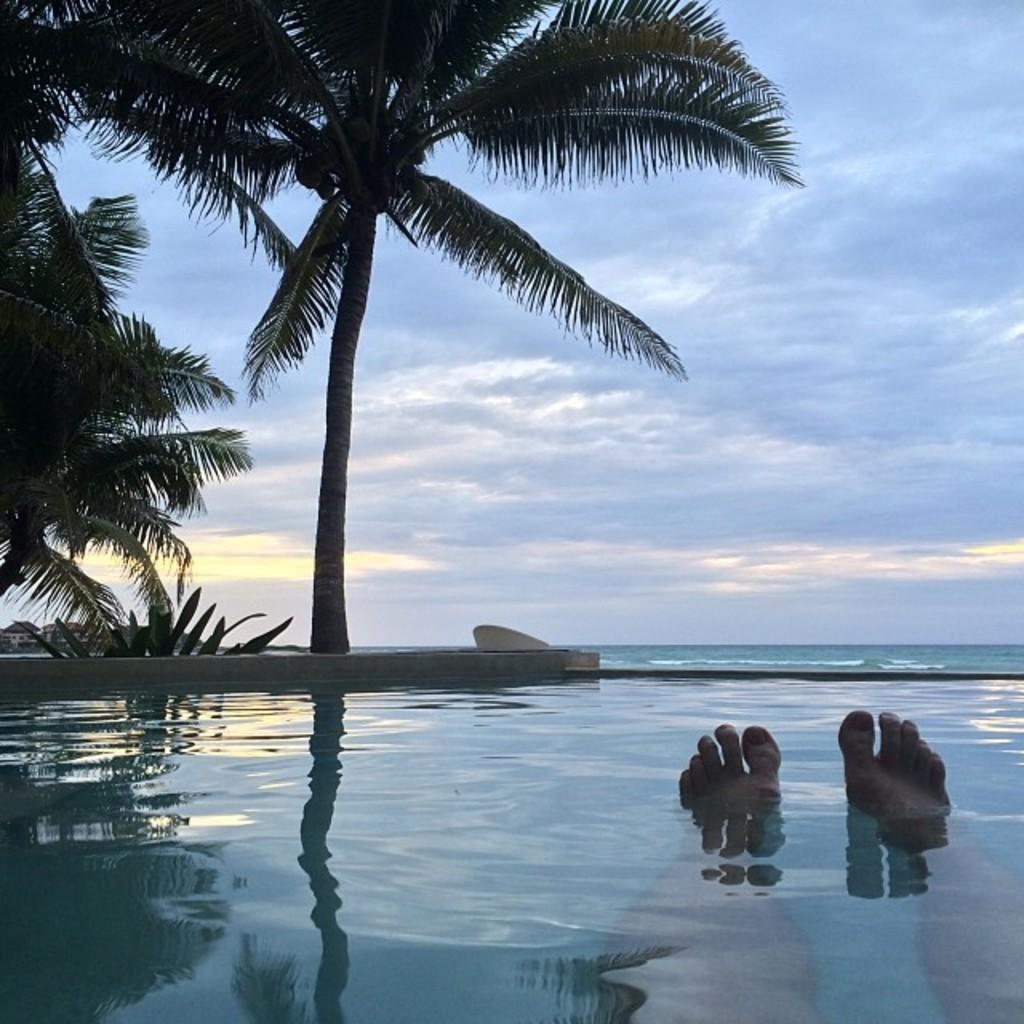What part of a person can be seen in the water in the image? There are legs of a person in the water in the image. What type of natural environment is visible in the image? There are trees visible in the image. What type of man-made structures can be seen in the background? There are buildings in the background. What part of the natural environment is visible in the background? The sky is visible in the background. What type of birds can be seen flying over the buildings in the image? There are no birds visible in the image; only the legs of a person in the water, trees, buildings, and sky can be seen. 